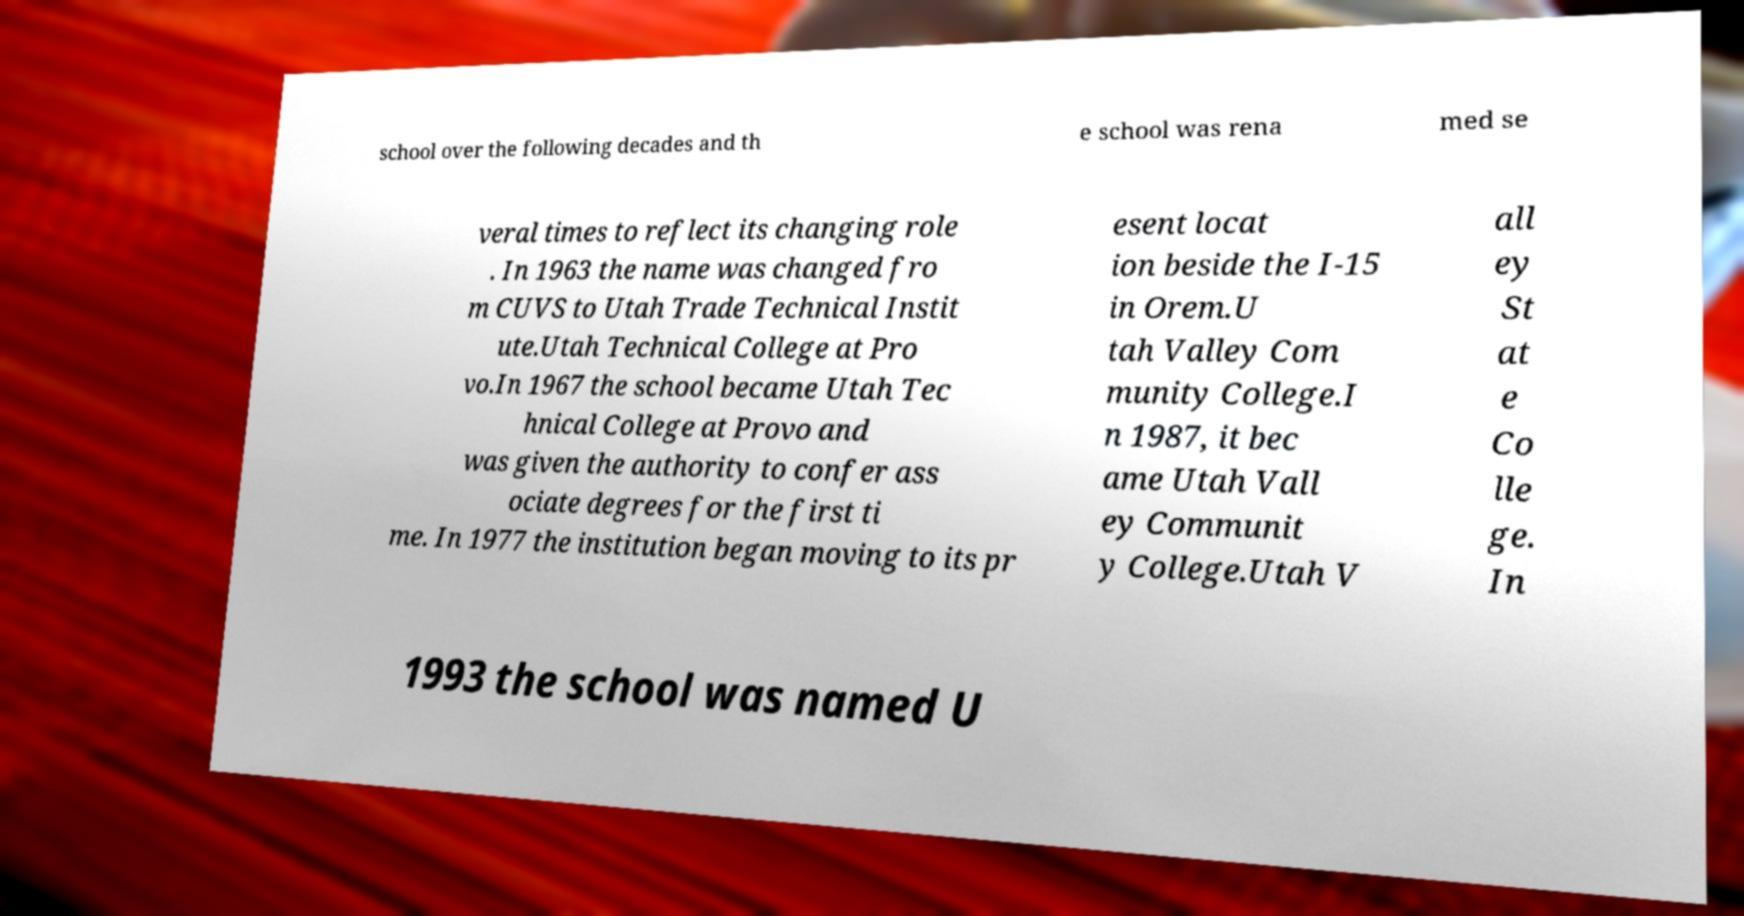There's text embedded in this image that I need extracted. Can you transcribe it verbatim? school over the following decades and th e school was rena med se veral times to reflect its changing role . In 1963 the name was changed fro m CUVS to Utah Trade Technical Instit ute.Utah Technical College at Pro vo.In 1967 the school became Utah Tec hnical College at Provo and was given the authority to confer ass ociate degrees for the first ti me. In 1977 the institution began moving to its pr esent locat ion beside the I-15 in Orem.U tah Valley Com munity College.I n 1987, it bec ame Utah Vall ey Communit y College.Utah V all ey St at e Co lle ge. In 1993 the school was named U 